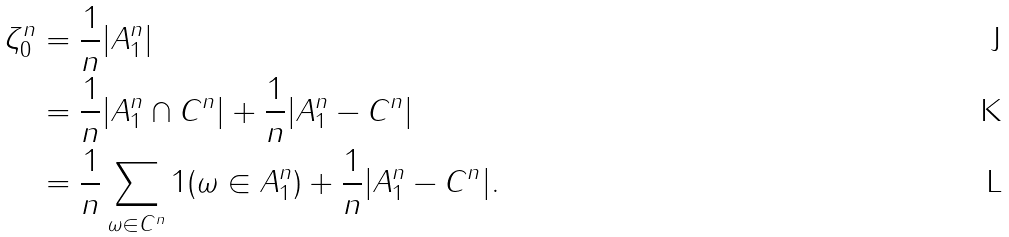<formula> <loc_0><loc_0><loc_500><loc_500>\zeta _ { 0 } ^ { n } & = \frac { 1 } { n } | A _ { 1 } ^ { n } | \\ & = \frac { 1 } { n } | A _ { 1 } ^ { n } \cap C ^ { n } | + \frac { 1 } { n } | A _ { 1 } ^ { n } - C ^ { n } | \\ & = \frac { 1 } { n } \sum _ { \omega \in C ^ { n } } 1 ( \omega \in A _ { 1 } ^ { n } ) + \frac { 1 } { n } | A _ { 1 } ^ { n } - C ^ { n } | .</formula> 